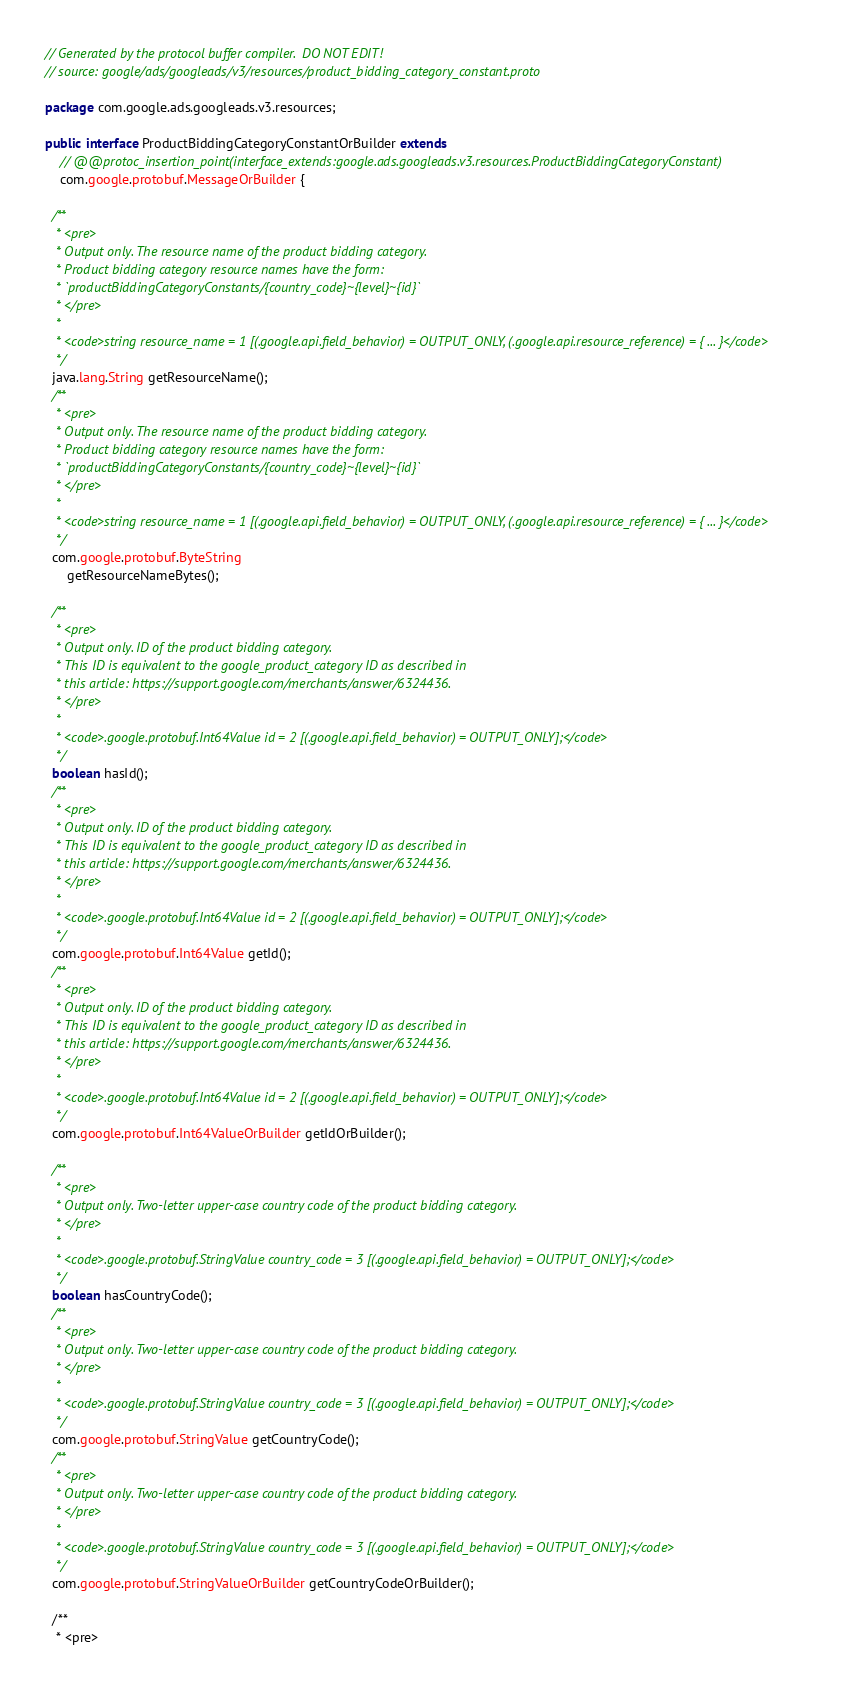<code> <loc_0><loc_0><loc_500><loc_500><_Java_>// Generated by the protocol buffer compiler.  DO NOT EDIT!
// source: google/ads/googleads/v3/resources/product_bidding_category_constant.proto

package com.google.ads.googleads.v3.resources;

public interface ProductBiddingCategoryConstantOrBuilder extends
    // @@protoc_insertion_point(interface_extends:google.ads.googleads.v3.resources.ProductBiddingCategoryConstant)
    com.google.protobuf.MessageOrBuilder {

  /**
   * <pre>
   * Output only. The resource name of the product bidding category.
   * Product bidding category resource names have the form:
   * `productBiddingCategoryConstants/{country_code}~{level}~{id}`
   * </pre>
   *
   * <code>string resource_name = 1 [(.google.api.field_behavior) = OUTPUT_ONLY, (.google.api.resource_reference) = { ... }</code>
   */
  java.lang.String getResourceName();
  /**
   * <pre>
   * Output only. The resource name of the product bidding category.
   * Product bidding category resource names have the form:
   * `productBiddingCategoryConstants/{country_code}~{level}~{id}`
   * </pre>
   *
   * <code>string resource_name = 1 [(.google.api.field_behavior) = OUTPUT_ONLY, (.google.api.resource_reference) = { ... }</code>
   */
  com.google.protobuf.ByteString
      getResourceNameBytes();

  /**
   * <pre>
   * Output only. ID of the product bidding category.
   * This ID is equivalent to the google_product_category ID as described in
   * this article: https://support.google.com/merchants/answer/6324436.
   * </pre>
   *
   * <code>.google.protobuf.Int64Value id = 2 [(.google.api.field_behavior) = OUTPUT_ONLY];</code>
   */
  boolean hasId();
  /**
   * <pre>
   * Output only. ID of the product bidding category.
   * This ID is equivalent to the google_product_category ID as described in
   * this article: https://support.google.com/merchants/answer/6324436.
   * </pre>
   *
   * <code>.google.protobuf.Int64Value id = 2 [(.google.api.field_behavior) = OUTPUT_ONLY];</code>
   */
  com.google.protobuf.Int64Value getId();
  /**
   * <pre>
   * Output only. ID of the product bidding category.
   * This ID is equivalent to the google_product_category ID as described in
   * this article: https://support.google.com/merchants/answer/6324436.
   * </pre>
   *
   * <code>.google.protobuf.Int64Value id = 2 [(.google.api.field_behavior) = OUTPUT_ONLY];</code>
   */
  com.google.protobuf.Int64ValueOrBuilder getIdOrBuilder();

  /**
   * <pre>
   * Output only. Two-letter upper-case country code of the product bidding category.
   * </pre>
   *
   * <code>.google.protobuf.StringValue country_code = 3 [(.google.api.field_behavior) = OUTPUT_ONLY];</code>
   */
  boolean hasCountryCode();
  /**
   * <pre>
   * Output only. Two-letter upper-case country code of the product bidding category.
   * </pre>
   *
   * <code>.google.protobuf.StringValue country_code = 3 [(.google.api.field_behavior) = OUTPUT_ONLY];</code>
   */
  com.google.protobuf.StringValue getCountryCode();
  /**
   * <pre>
   * Output only. Two-letter upper-case country code of the product bidding category.
   * </pre>
   *
   * <code>.google.protobuf.StringValue country_code = 3 [(.google.api.field_behavior) = OUTPUT_ONLY];</code>
   */
  com.google.protobuf.StringValueOrBuilder getCountryCodeOrBuilder();

  /**
   * <pre></code> 